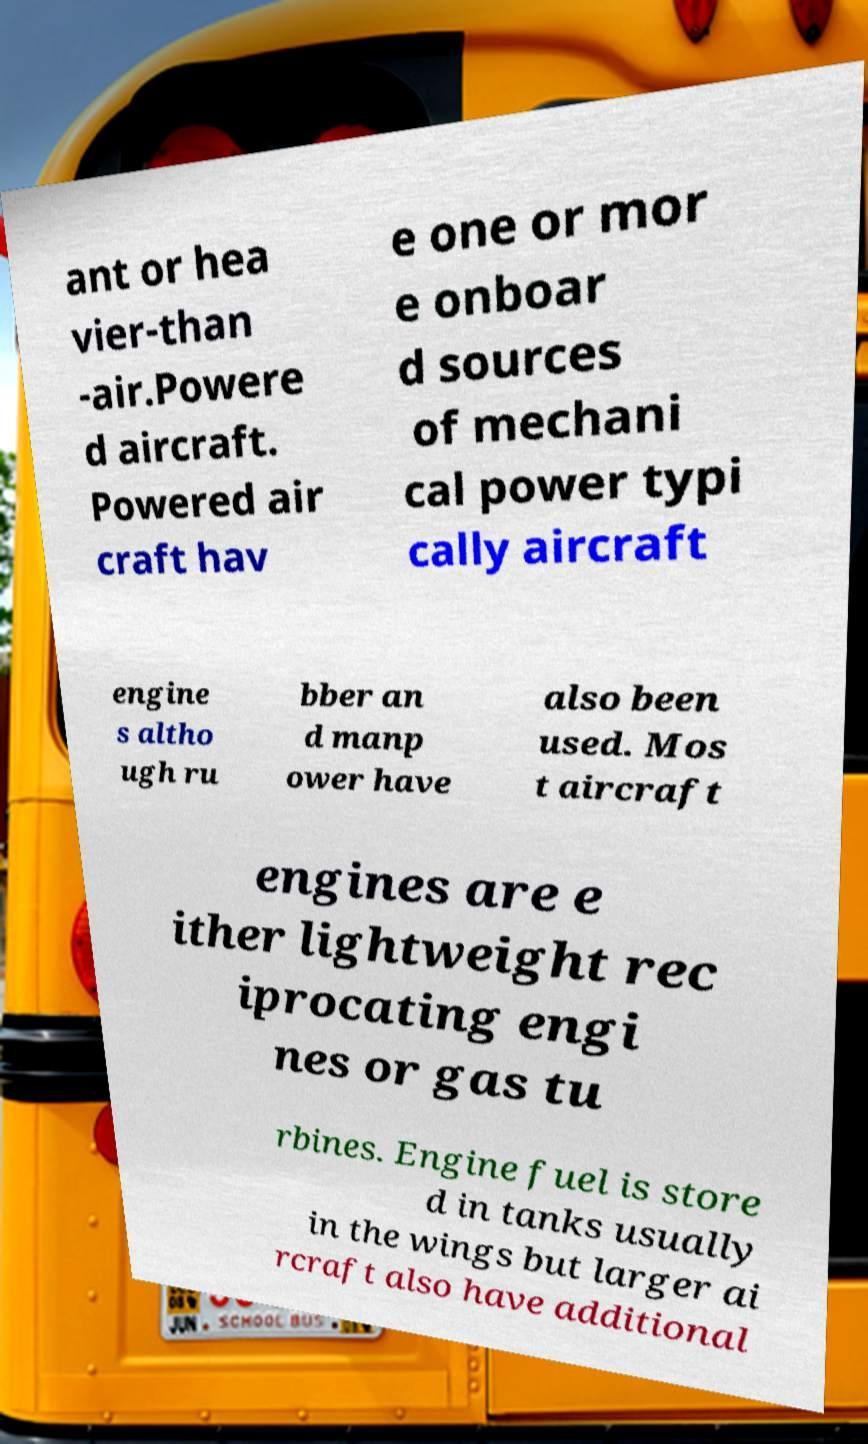Can you accurately transcribe the text from the provided image for me? ant or hea vier-than -air.Powere d aircraft. Powered air craft hav e one or mor e onboar d sources of mechani cal power typi cally aircraft engine s altho ugh ru bber an d manp ower have also been used. Mos t aircraft engines are e ither lightweight rec iprocating engi nes or gas tu rbines. Engine fuel is store d in tanks usually in the wings but larger ai rcraft also have additional 